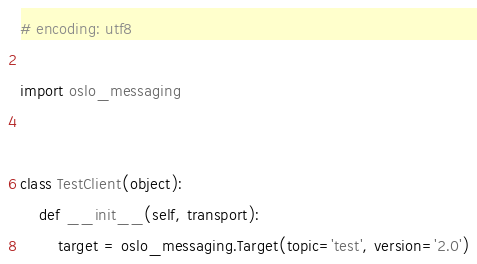Convert code to text. <code><loc_0><loc_0><loc_500><loc_500><_Python_># encoding: utf8

import oslo_messaging


class TestClient(object):
    def __init__(self, transport):
        target = oslo_messaging.Target(topic='test', version='2.0')</code> 